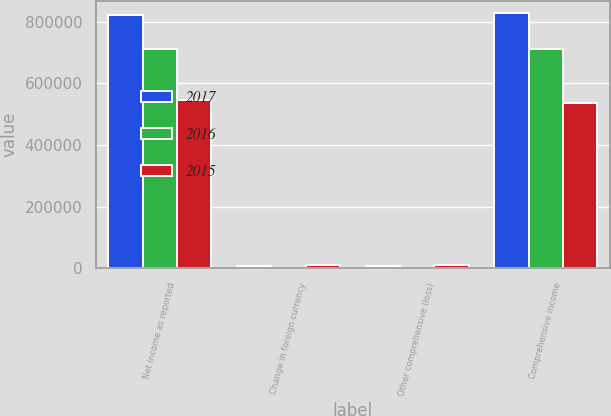<chart> <loc_0><loc_0><loc_500><loc_500><stacked_bar_chart><ecel><fcel>Net income as reported<fcel>Change in foreign currency<fcel>Other comprehensive (loss)<fcel>Comprehensive income<nl><fcel>2017<fcel>820678<fcel>7238<fcel>6590<fcel>827268<nl><fcel>2016<fcel>712685<fcel>1178<fcel>1371<fcel>711314<nl><fcel>2015<fcel>546733<fcel>10425<fcel>10425<fcel>536308<nl></chart> 